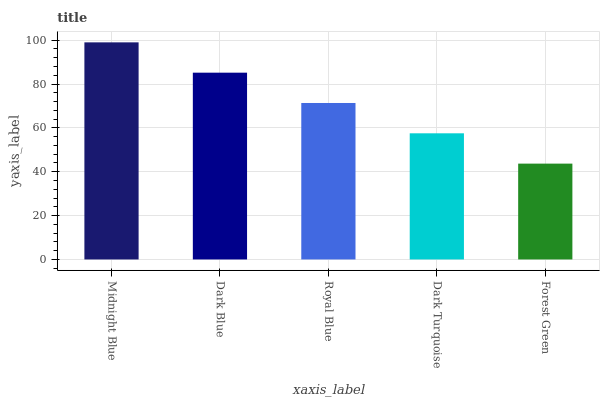Is Forest Green the minimum?
Answer yes or no. Yes. Is Midnight Blue the maximum?
Answer yes or no. Yes. Is Dark Blue the minimum?
Answer yes or no. No. Is Dark Blue the maximum?
Answer yes or no. No. Is Midnight Blue greater than Dark Blue?
Answer yes or no. Yes. Is Dark Blue less than Midnight Blue?
Answer yes or no. Yes. Is Dark Blue greater than Midnight Blue?
Answer yes or no. No. Is Midnight Blue less than Dark Blue?
Answer yes or no. No. Is Royal Blue the high median?
Answer yes or no. Yes. Is Royal Blue the low median?
Answer yes or no. Yes. Is Forest Green the high median?
Answer yes or no. No. Is Dark Turquoise the low median?
Answer yes or no. No. 